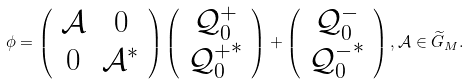<formula> <loc_0><loc_0><loc_500><loc_500>\phi = \left ( \begin{array} { c c } \mathcal { A } & 0 \\ 0 & \mathcal { A } ^ { * } \end{array} \right ) \left ( \begin{array} { c } \mathcal { Q } ^ { + } _ { 0 } \\ { \mathcal { Q } ^ { + } _ { 0 } } ^ { * } \end{array} \right ) + \left ( \begin{array} { c } \mathcal { Q } ^ { - } _ { 0 } \\ { \mathcal { Q } ^ { - } _ { 0 } } ^ { * } \end{array} \right ) , \mathcal { A } \in \widetilde { G } _ { M } .</formula> 